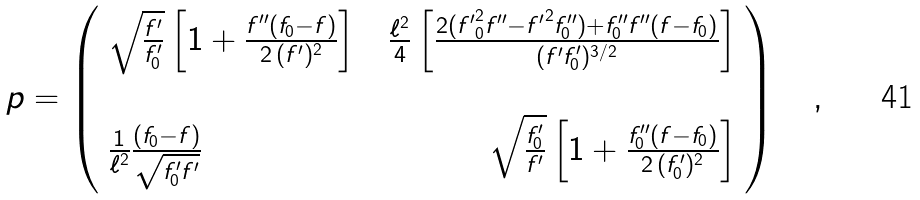Convert formula to latex. <formula><loc_0><loc_0><loc_500><loc_500>p = \left ( \begin{array} { l c r } \sqrt { \frac { f ^ { \prime } } { f ^ { \prime } _ { 0 } } } \left [ 1 + \frac { f ^ { \prime \prime } ( f _ { 0 } - f ) } { 2 \, ( f ^ { \prime } ) ^ { 2 } } \right ] & & \frac { \ell ^ { 2 } } { 4 } \left [ \frac { 2 ( { f ^ { \prime } } _ { 0 } ^ { 2 } f ^ { \prime \prime } - { f ^ { \prime } } ^ { 2 } f ^ { \prime \prime } _ { 0 } ) + f ^ { \prime \prime } _ { 0 } f ^ { \prime \prime } ( f - f _ { 0 } ) } { ( f ^ { \prime } f ^ { \prime } _ { 0 } ) ^ { 3 / 2 } } \right ] \\ & & \\ \frac { 1 } { \ell ^ { 2 } } \frac { ( f _ { 0 } - f ) } { \sqrt { f ^ { \prime } _ { 0 } f ^ { \prime } } } & & \sqrt { \frac { f ^ { \prime } _ { 0 } } { f ^ { \prime } } } \left [ 1 + \frac { f ^ { \prime \prime } _ { 0 } ( f - f _ { 0 } ) } { 2 \, ( f _ { 0 } ^ { \prime } ) ^ { 2 } } \right ] \end{array} \right ) \quad ,</formula> 